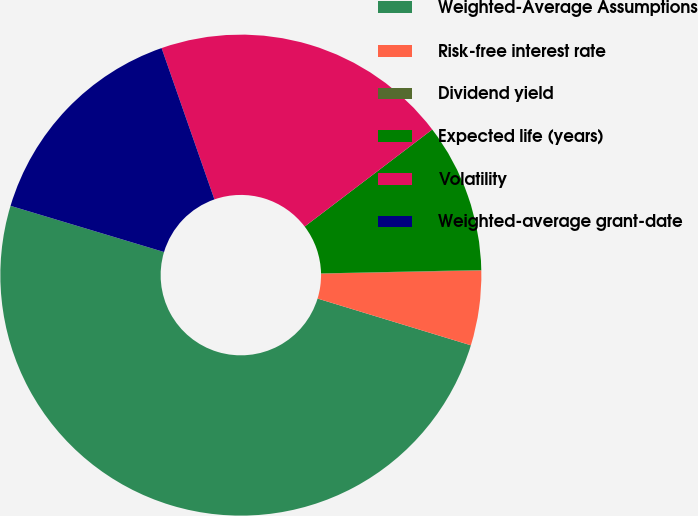Convert chart to OTSL. <chart><loc_0><loc_0><loc_500><loc_500><pie_chart><fcel>Weighted-Average Assumptions<fcel>Risk-free interest rate<fcel>Dividend yield<fcel>Expected life (years)<fcel>Volatility<fcel>Weighted-average grant-date<nl><fcel>49.93%<fcel>5.02%<fcel>0.03%<fcel>10.01%<fcel>19.99%<fcel>15.0%<nl></chart> 